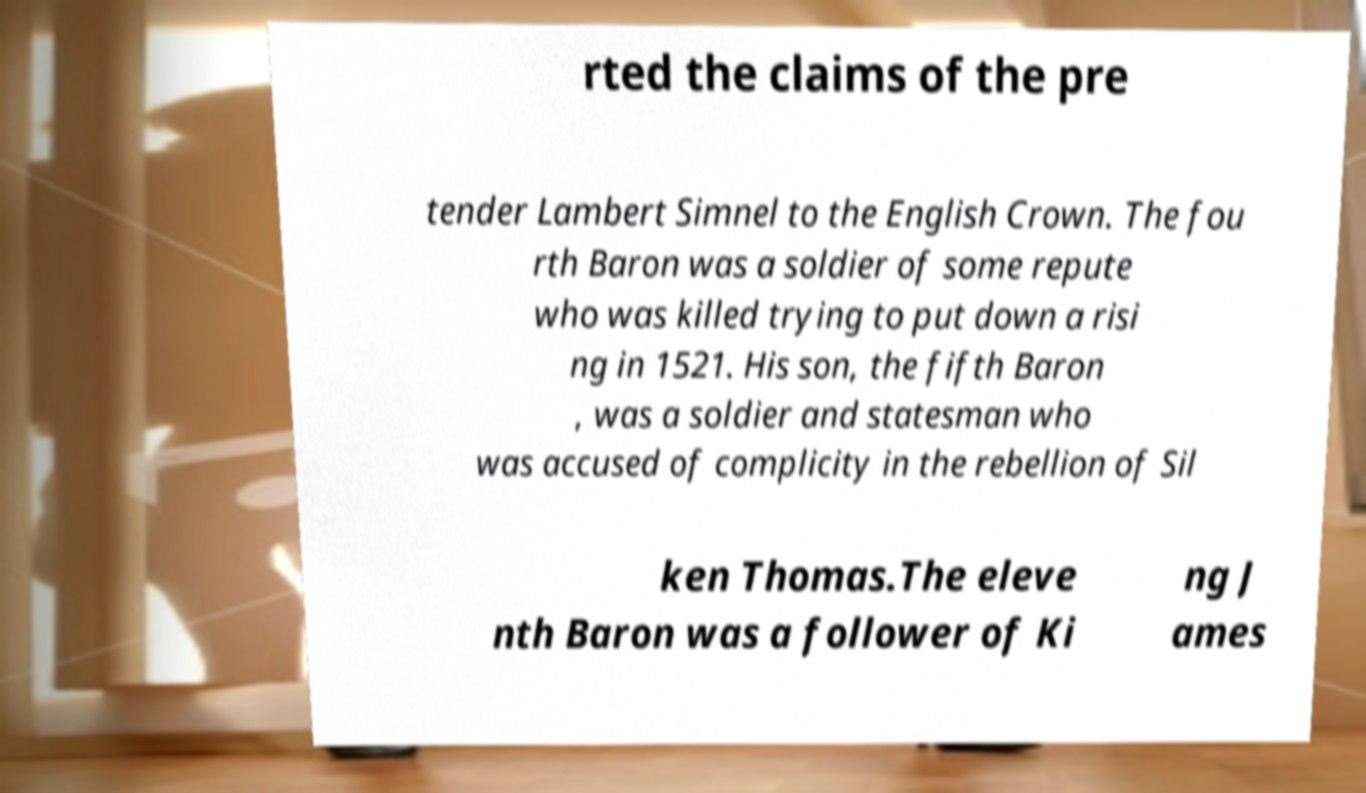There's text embedded in this image that I need extracted. Can you transcribe it verbatim? rted the claims of the pre tender Lambert Simnel to the English Crown. The fou rth Baron was a soldier of some repute who was killed trying to put down a risi ng in 1521. His son, the fifth Baron , was a soldier and statesman who was accused of complicity in the rebellion of Sil ken Thomas.The eleve nth Baron was a follower of Ki ng J ames 